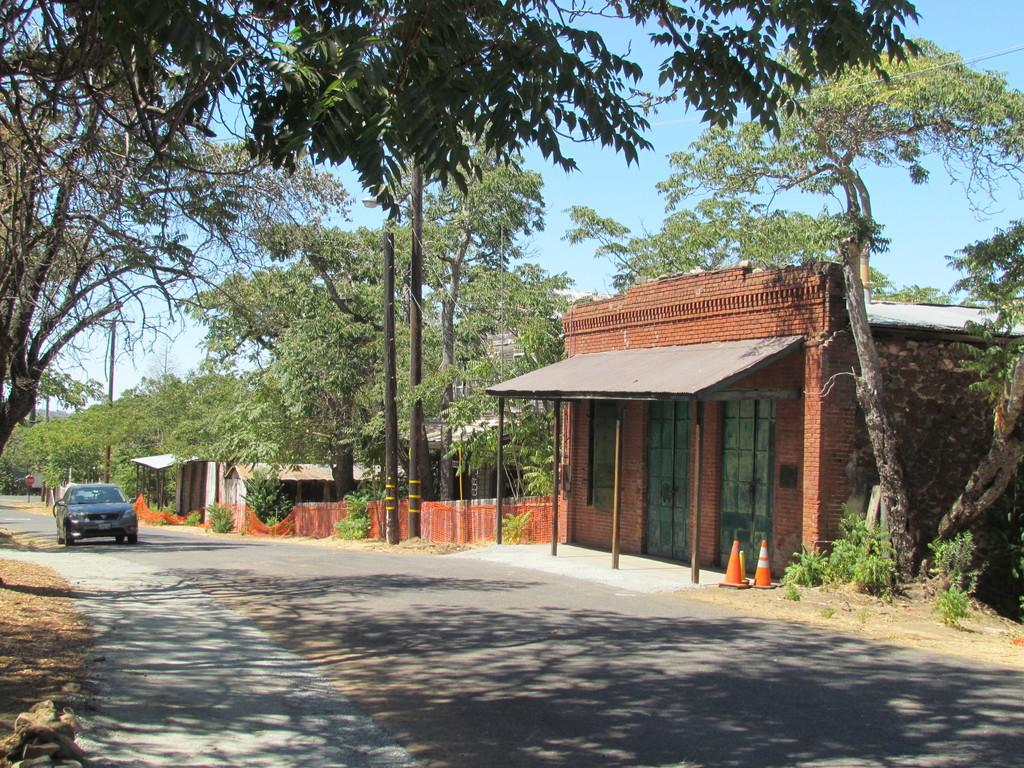What is the main subject of the image? The main subject of the image is a car on the road. What can be seen on the right side of the image? There are buildings, trees, and traffic cones on the right side of the image. What is visible in the background of the image? The sky is visible in the background of the image. What type of plastic is covering the jar in the image? There is no jar or plastic present in the image. Can you see the moon in the image? The image does not show the moon; it only shows a car on the road, buildings, trees, traffic cones, and the sky. 